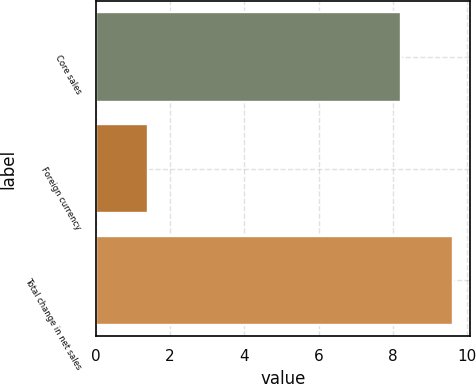Convert chart. <chart><loc_0><loc_0><loc_500><loc_500><bar_chart><fcel>Core sales<fcel>Foreign currency<fcel>Total change in net sales<nl><fcel>8.2<fcel>1.4<fcel>9.6<nl></chart> 